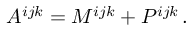<formula> <loc_0><loc_0><loc_500><loc_500>A ^ { i j k } = M ^ { i j k } + P ^ { i j k } \, .</formula> 